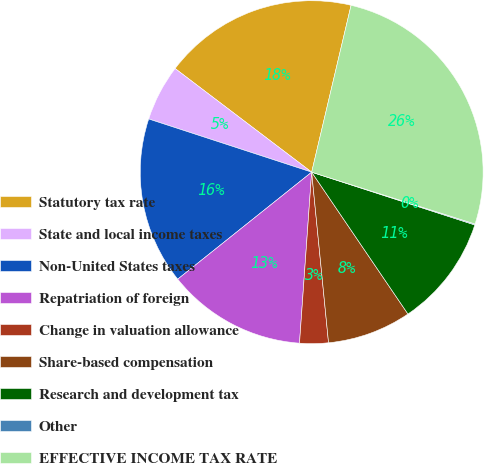Convert chart to OTSL. <chart><loc_0><loc_0><loc_500><loc_500><pie_chart><fcel>Statutory tax rate<fcel>State and local income taxes<fcel>Non-United States taxes<fcel>Repatriation of foreign<fcel>Change in valuation allowance<fcel>Share-based compensation<fcel>Research and development tax<fcel>Other<fcel>EFFECTIVE INCOME TAX RATE<nl><fcel>18.36%<fcel>5.31%<fcel>15.75%<fcel>13.14%<fcel>2.7%<fcel>7.92%<fcel>10.53%<fcel>0.09%<fcel>26.2%<nl></chart> 